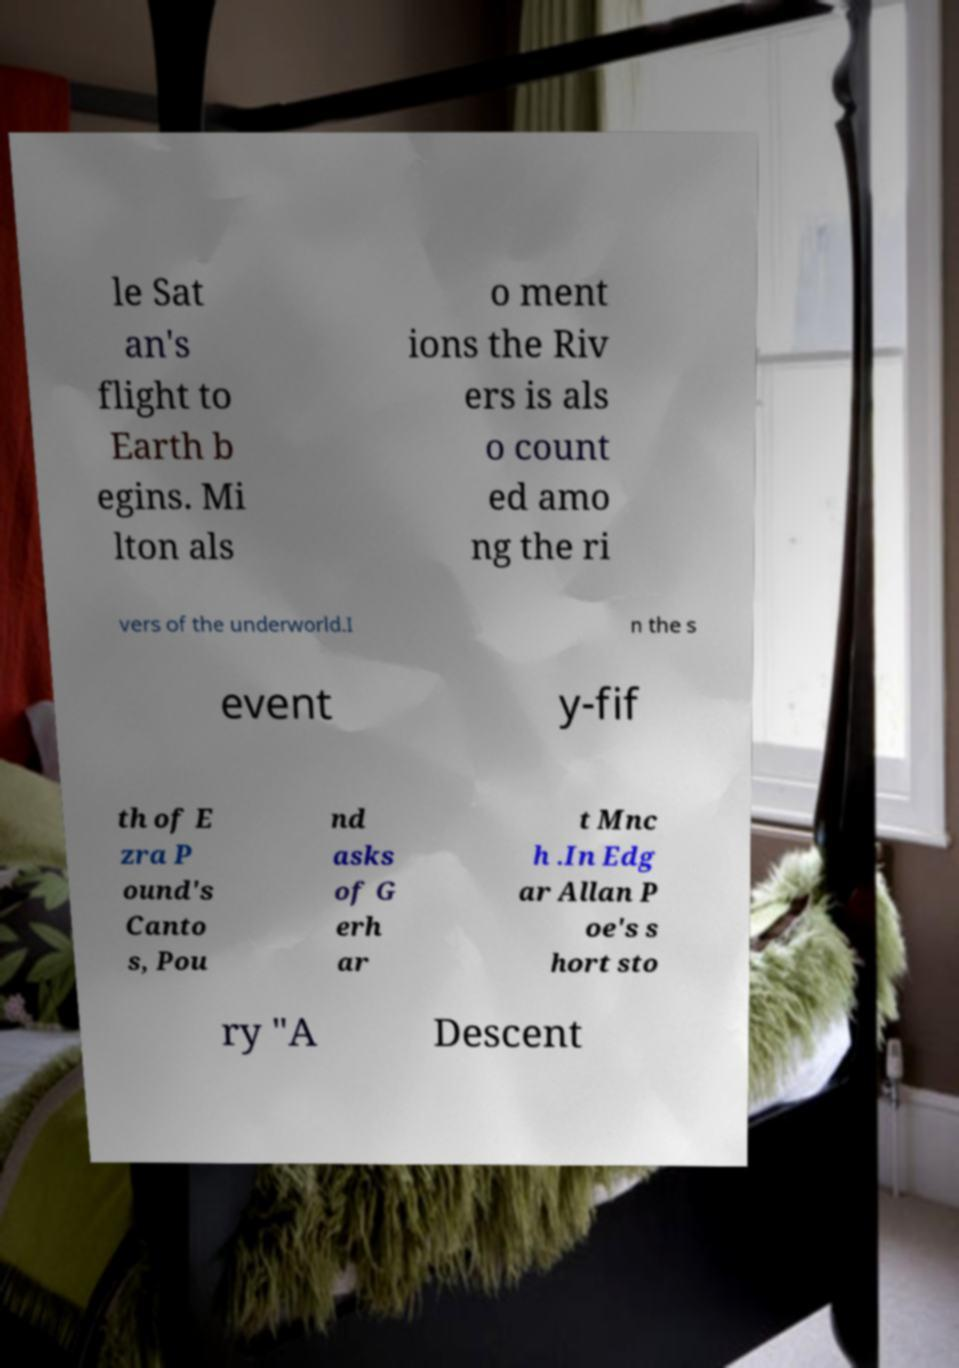Can you read and provide the text displayed in the image?This photo seems to have some interesting text. Can you extract and type it out for me? le Sat an's flight to Earth b egins. Mi lton als o ment ions the Riv ers is als o count ed amo ng the ri vers of the underworld.I n the s event y-fif th of E zra P ound's Canto s, Pou nd asks of G erh ar t Mnc h .In Edg ar Allan P oe's s hort sto ry "A Descent 